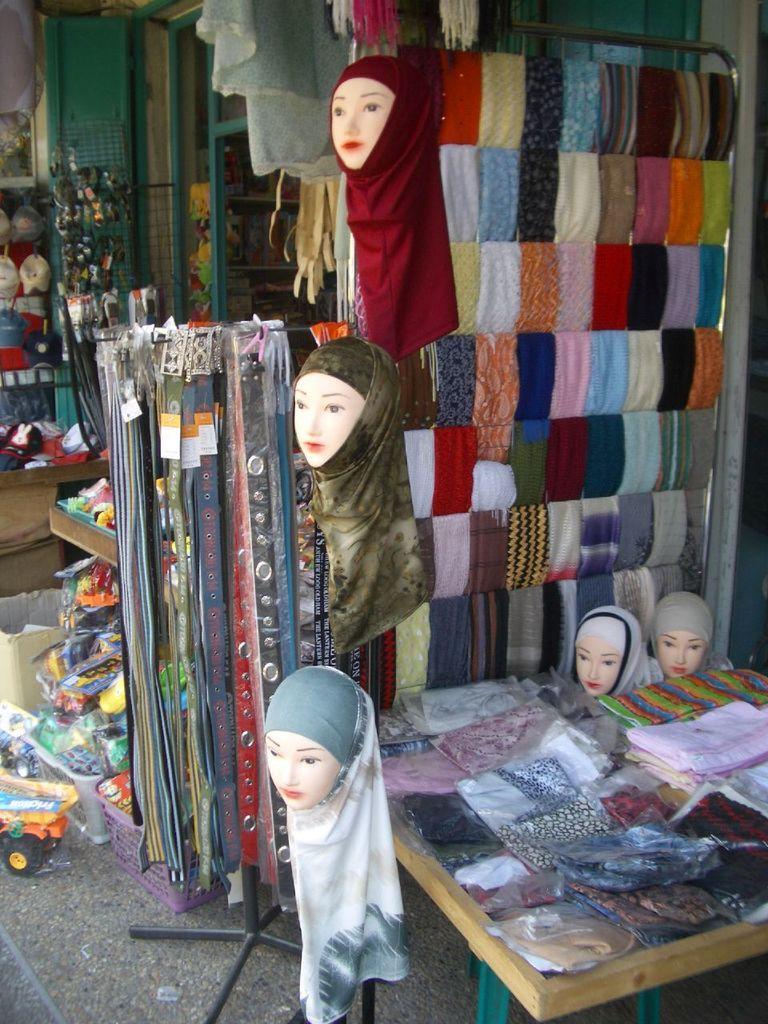Please provide a concise description of this image. In this image I can see few faces of the mannequin and I can see few multi color clothes. I can also see few belts, background I can see few toys in multi color. 